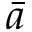Convert formula to latex. <formula><loc_0><loc_0><loc_500><loc_500>\bar { a }</formula> 